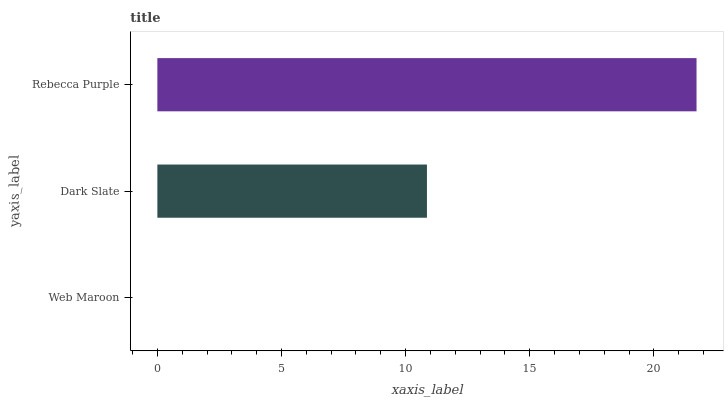Is Web Maroon the minimum?
Answer yes or no. Yes. Is Rebecca Purple the maximum?
Answer yes or no. Yes. Is Dark Slate the minimum?
Answer yes or no. No. Is Dark Slate the maximum?
Answer yes or no. No. Is Dark Slate greater than Web Maroon?
Answer yes or no. Yes. Is Web Maroon less than Dark Slate?
Answer yes or no. Yes. Is Web Maroon greater than Dark Slate?
Answer yes or no. No. Is Dark Slate less than Web Maroon?
Answer yes or no. No. Is Dark Slate the high median?
Answer yes or no. Yes. Is Dark Slate the low median?
Answer yes or no. Yes. Is Rebecca Purple the high median?
Answer yes or no. No. Is Rebecca Purple the low median?
Answer yes or no. No. 